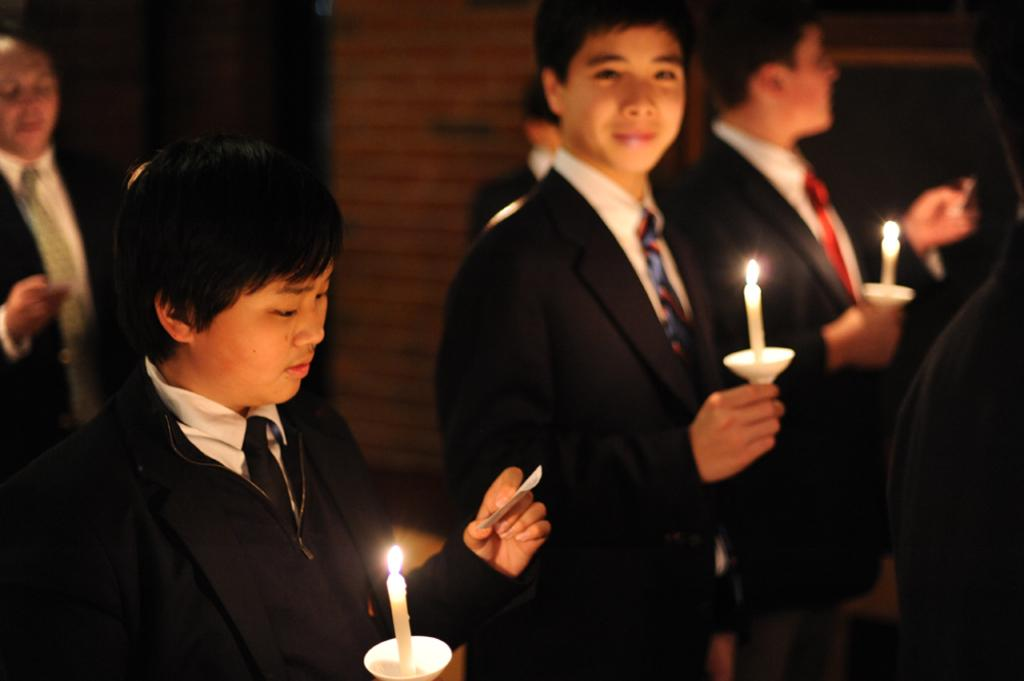What is the main subject of the image? The main subject of the image is a group of people. What are some of the people in the group holding? Some people in the group are holding candles, while others are holding papers. What type of berry can be seen growing on the people in the image? There are no berries present in the image; the people are holding candles and papers. 